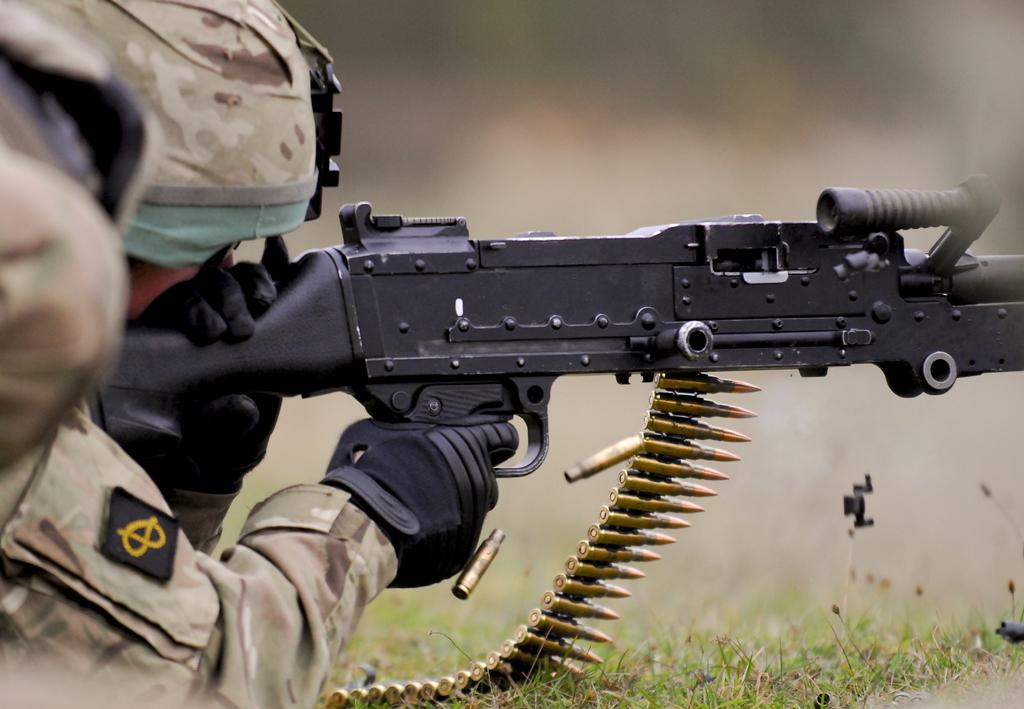Who is present in the image? There is a man in the image. What is the man wearing? The man is wearing a camouflage dress. Where is the man located? The man is laying on grassland. What is the man holding in the image? The man is holding a gun. What is the condition of the gun? The gun has bullets in it. Can you see a drain in the image? There is no drain present in the image; it features a man laying on grassland and holding a gun. 